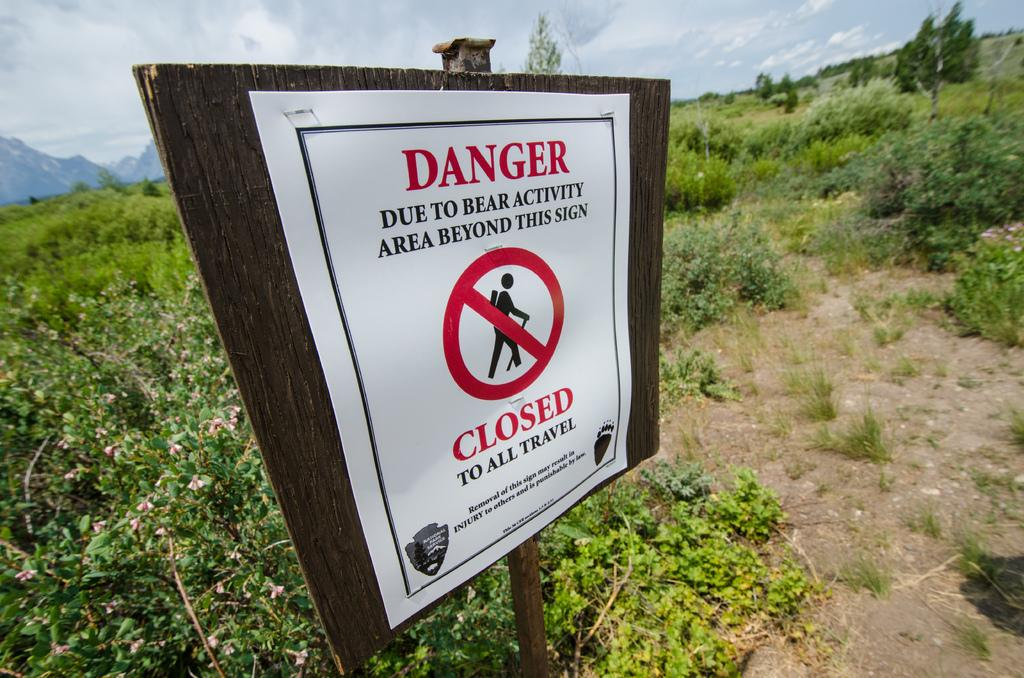What is the paper attached to in the image? The paper is attached to a wooden board. What type of natural elements can be seen in the image? There are trees and plants visible in the image. What geographical feature is visible in the background of the image? There are mountains in the background of the image. What is visible in the sky in the image? Clouds are present in the sky. How many eyes can be seen on the wooden board in the image? There are no eyes present on the wooden board or in the image. 